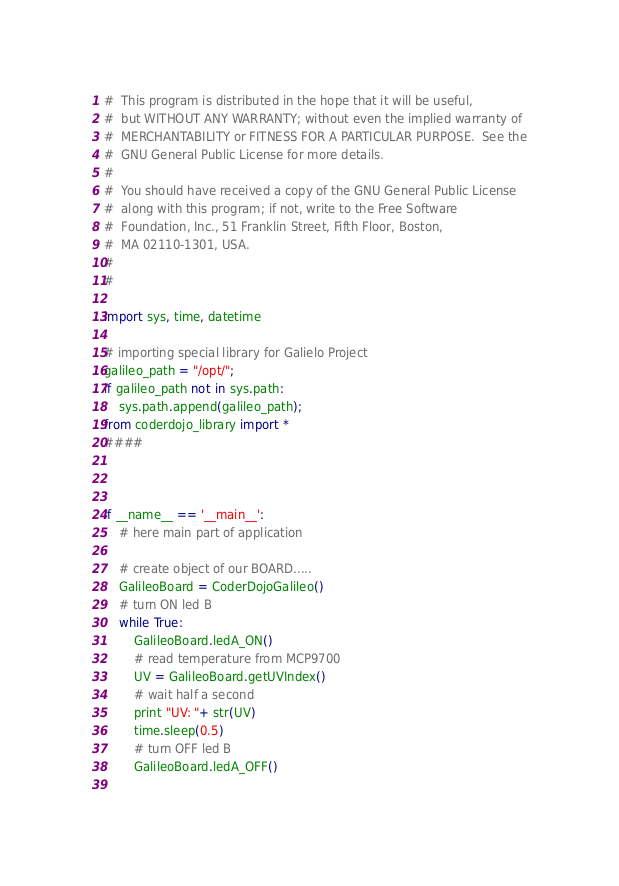Convert code to text. <code><loc_0><loc_0><loc_500><loc_500><_Python_>#  This program is distributed in the hope that it will be useful,
#  but WITHOUT ANY WARRANTY; without even the implied warranty of
#  MERCHANTABILITY or FITNESS FOR A PARTICULAR PURPOSE.  See the
#  GNU General Public License for more details.
#  
#  You should have received a copy of the GNU General Public License
#  along with this program; if not, write to the Free Software
#  Foundation, Inc., 51 Franklin Street, Fifth Floor, Boston,
#  MA 02110-1301, USA.
#  
#  

import sys, time, datetime

# importing special library for Galielo Project
galileo_path = "/opt/";
if galileo_path not in sys.path:
    sys.path.append(galileo_path);
from coderdojo_library import *
####



if __name__ == '__main__':
	# here main part of application
	
	# create object of our BOARD.....
	GalileoBoard = CoderDojoGalileo()
	# turn ON led B
	while True:
		GalileoBoard.ledA_ON()
		# read temperature from MCP9700 
		UV = GalileoBoard.getUVIndex()
		# wait half a second
		print "UV: "+ str(UV)
		time.sleep(0.5)
		# turn OFF led B
		GalileoBoard.ledA_OFF()
	

</code> 